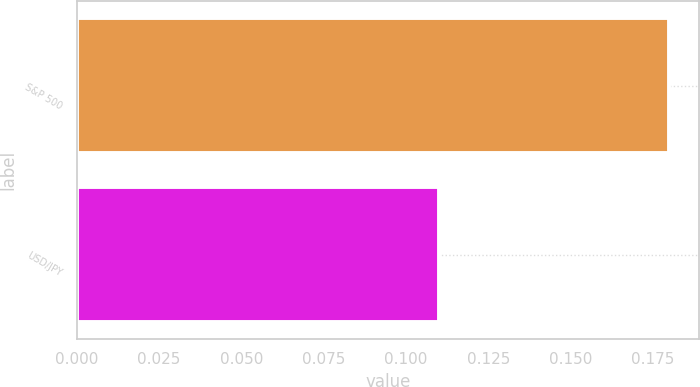<chart> <loc_0><loc_0><loc_500><loc_500><bar_chart><fcel>S&P 500<fcel>USD/JPY<nl><fcel>0.18<fcel>0.11<nl></chart> 